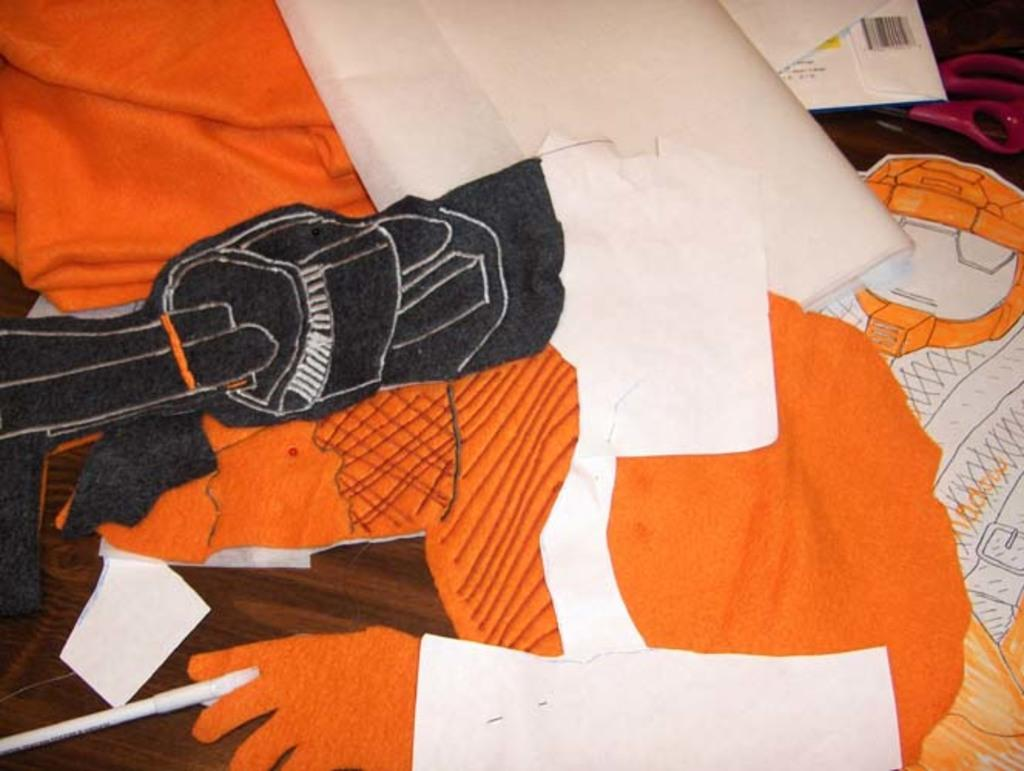What type of items can be seen in the image? There are clothes in the image. What color are the clothes? The clothes are in orange color. How many rabbits are present in the image? There are no rabbits present in the image; it only features clothes in orange color. 